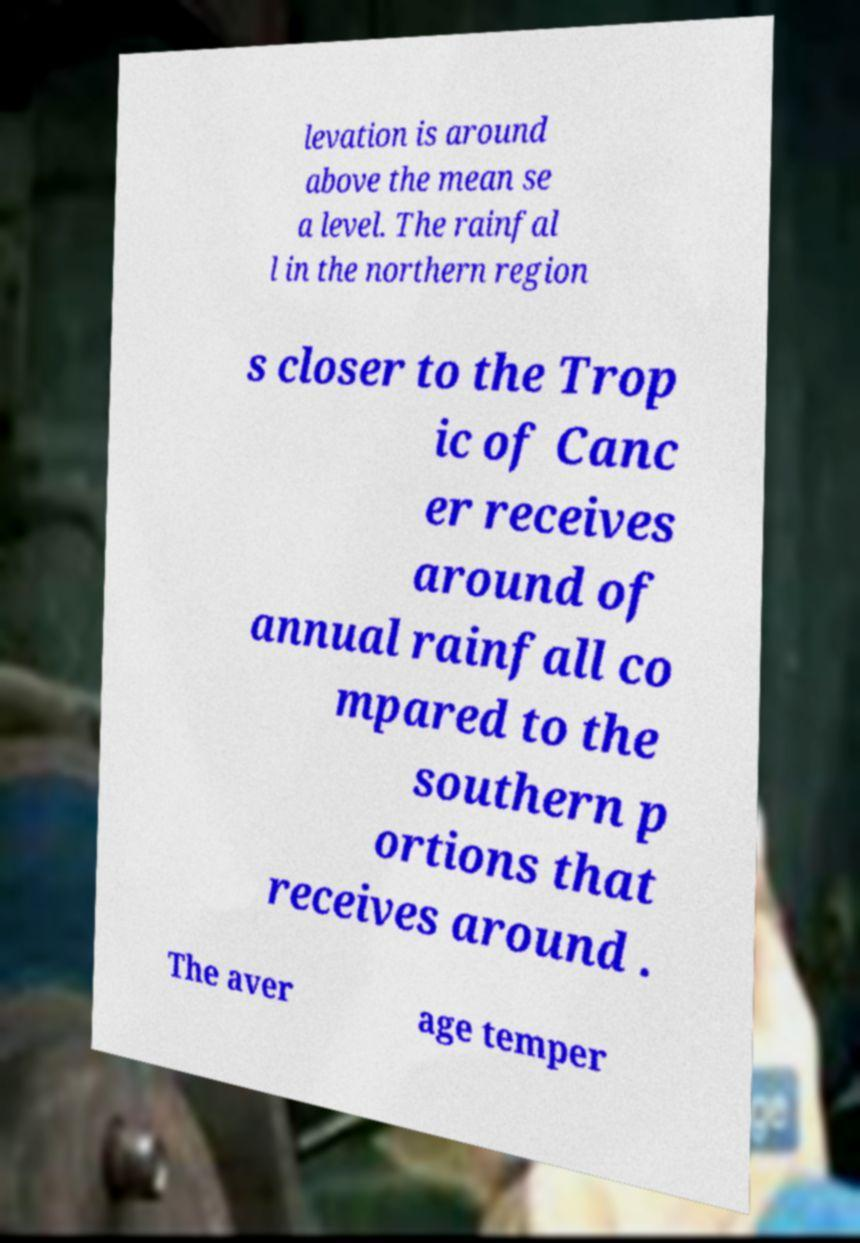Please read and relay the text visible in this image. What does it say? levation is around above the mean se a level. The rainfal l in the northern region s closer to the Trop ic of Canc er receives around of annual rainfall co mpared to the southern p ortions that receives around . The aver age temper 